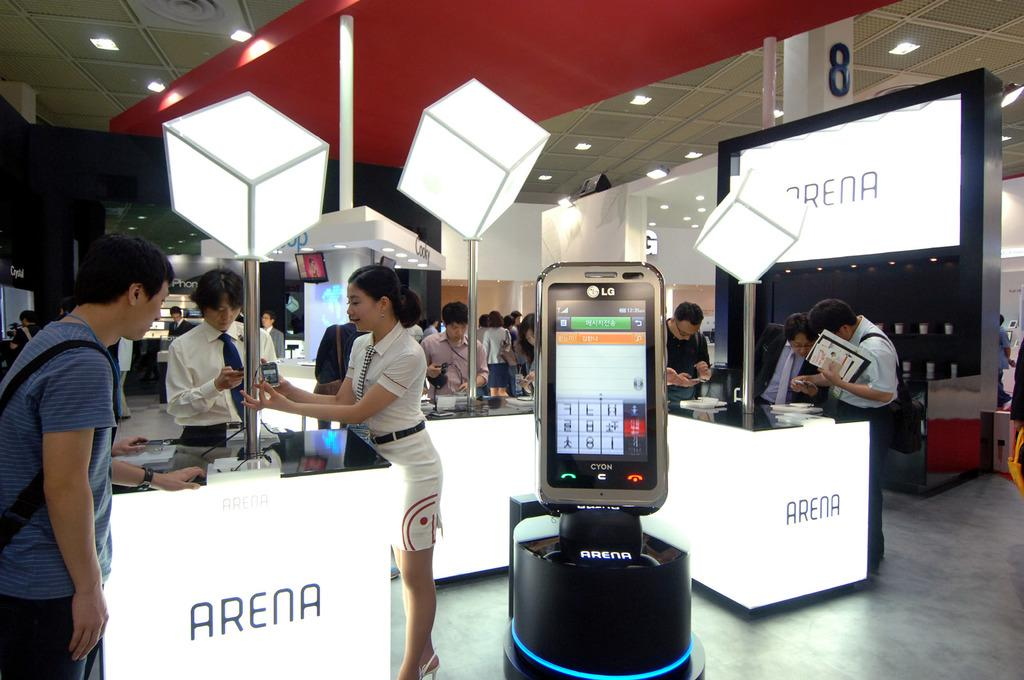What is happening in the image? There are people standing in the image. What object can be seen in the front of the image? There is a mobile phone in the front of the image. What is the color of the wall in the image? There is a white color wall in the image. How many patches are on the apples in the image? There are no apples present in the image, so it is not possible to determine the number of patches on any apples. 